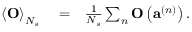Convert formula to latex. <formula><loc_0><loc_0><loc_500><loc_500>\begin{array} { r l r } { \left \langle O \right \rangle _ { N _ { s } } } & = } & { \frac { 1 } { N _ { s } } \sum _ { n } O \left ( a ^ { \left ( n \right ) } \right ) . } \end{array}</formula> 